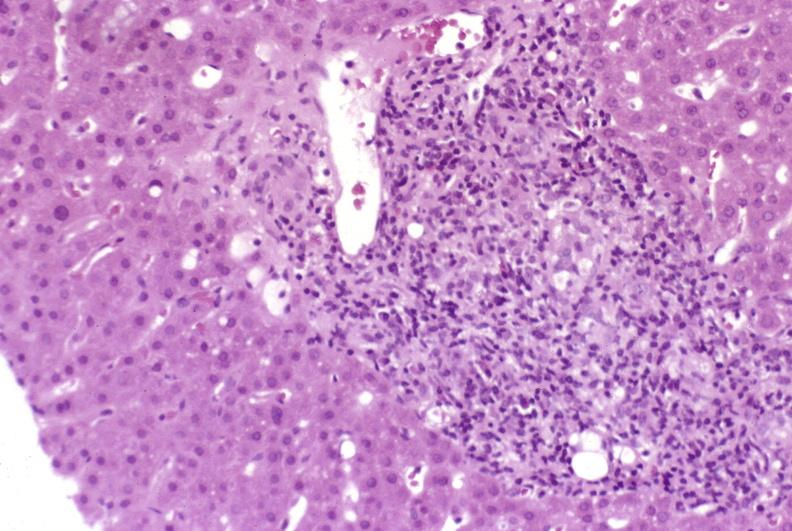s supernumerary digits present?
Answer the question using a single word or phrase. No 